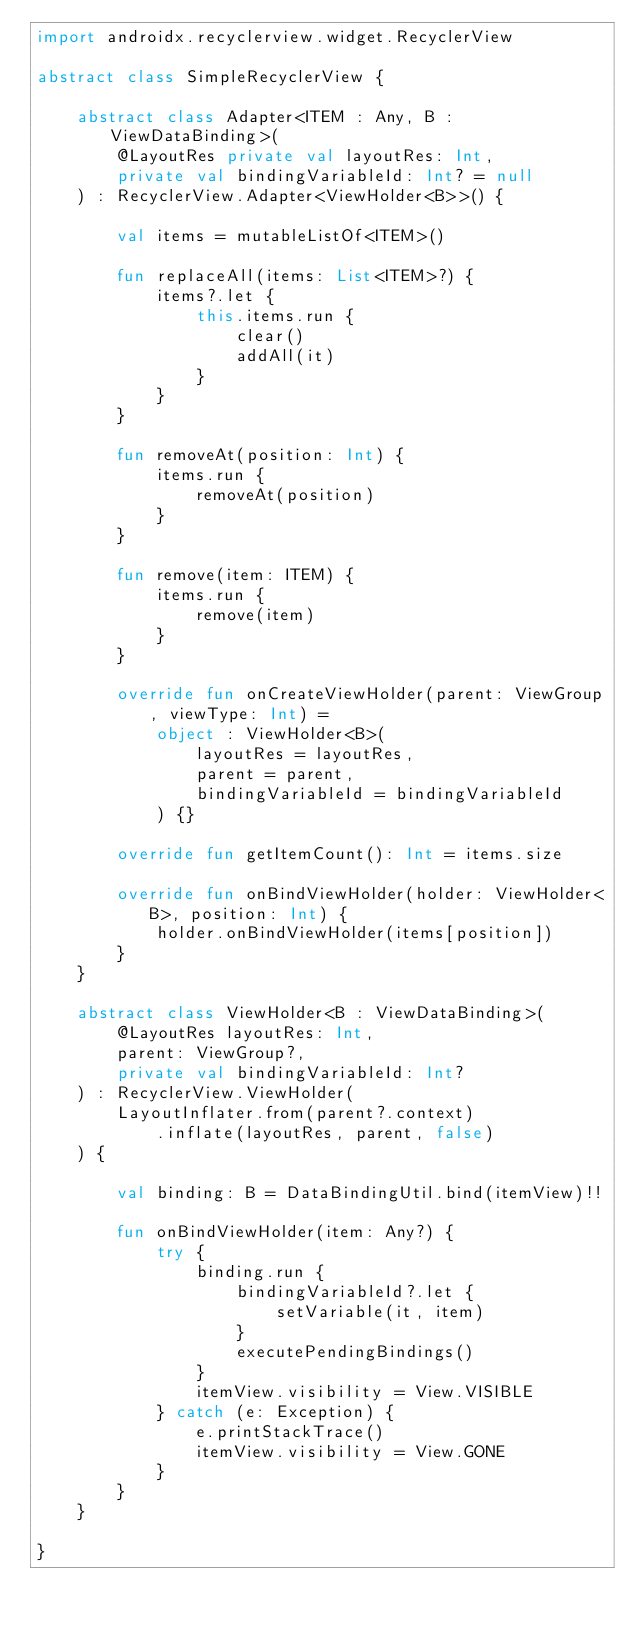<code> <loc_0><loc_0><loc_500><loc_500><_Kotlin_>import androidx.recyclerview.widget.RecyclerView

abstract class SimpleRecyclerView {

    abstract class Adapter<ITEM : Any, B : ViewDataBinding>(
        @LayoutRes private val layoutRes: Int,
        private val bindingVariableId: Int? = null
    ) : RecyclerView.Adapter<ViewHolder<B>>() {

        val items = mutableListOf<ITEM>()

        fun replaceAll(items: List<ITEM>?) {
            items?.let {
                this.items.run {
                    clear()
                    addAll(it)
                }
            }
        }

        fun removeAt(position: Int) {
            items.run {
                removeAt(position)
            }
        }

        fun remove(item: ITEM) {
            items.run {
                remove(item)
            }
        }

        override fun onCreateViewHolder(parent: ViewGroup, viewType: Int) =
            object : ViewHolder<B>(
                layoutRes = layoutRes,
                parent = parent,
                bindingVariableId = bindingVariableId
            ) {}

        override fun getItemCount(): Int = items.size

        override fun onBindViewHolder(holder: ViewHolder<B>, position: Int) {
            holder.onBindViewHolder(items[position])
        }
    }

    abstract class ViewHolder<B : ViewDataBinding>(
        @LayoutRes layoutRes: Int,
        parent: ViewGroup?,
        private val bindingVariableId: Int?
    ) : RecyclerView.ViewHolder(
        LayoutInflater.from(parent?.context)
            .inflate(layoutRes, parent, false)
    ) {

        val binding: B = DataBindingUtil.bind(itemView)!!

        fun onBindViewHolder(item: Any?) {
            try {
                binding.run {
                    bindingVariableId?.let {
                        setVariable(it, item)
                    }
                    executePendingBindings()
                }
                itemView.visibility = View.VISIBLE
            } catch (e: Exception) {
                e.printStackTrace()
                itemView.visibility = View.GONE
            }
        }
    }

}</code> 